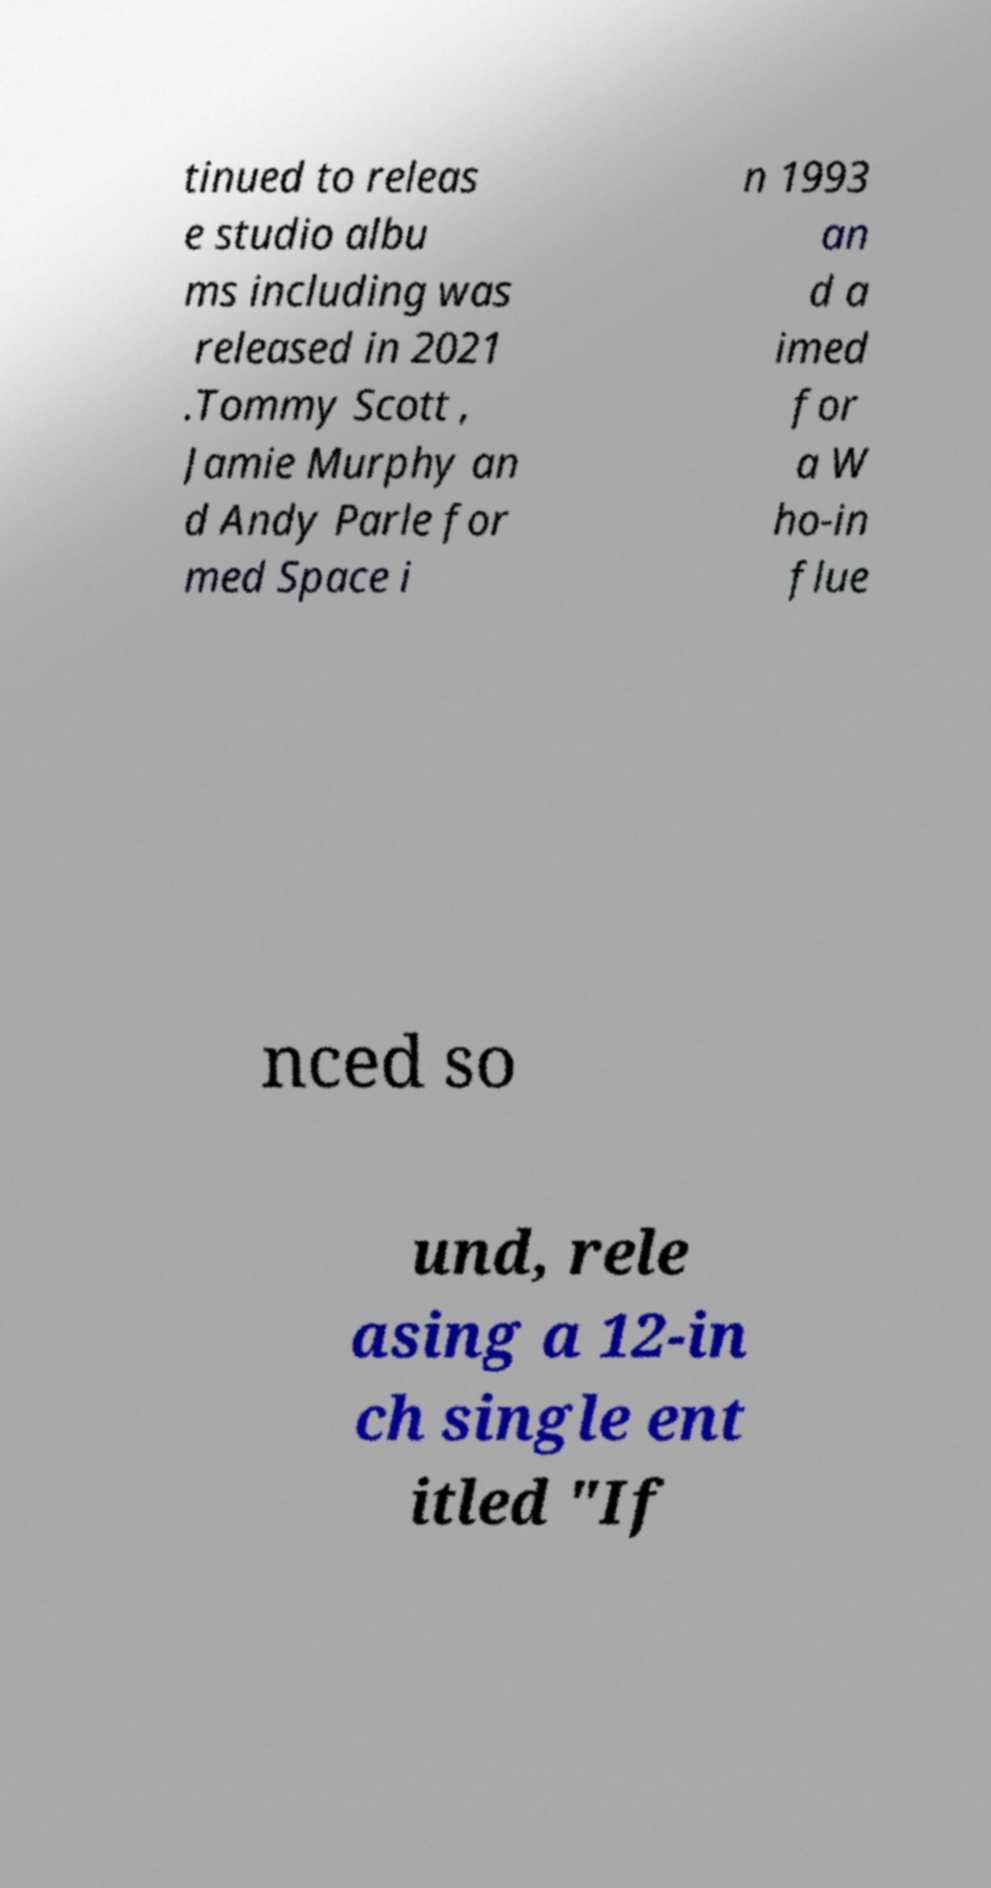Could you extract and type out the text from this image? tinued to releas e studio albu ms including was released in 2021 .Tommy Scott , Jamie Murphy an d Andy Parle for med Space i n 1993 an d a imed for a W ho-in flue nced so und, rele asing a 12-in ch single ent itled "If 